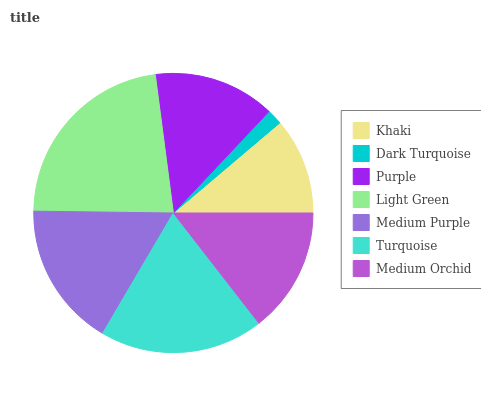Is Dark Turquoise the minimum?
Answer yes or no. Yes. Is Light Green the maximum?
Answer yes or no. Yes. Is Purple the minimum?
Answer yes or no. No. Is Purple the maximum?
Answer yes or no. No. Is Purple greater than Dark Turquoise?
Answer yes or no. Yes. Is Dark Turquoise less than Purple?
Answer yes or no. Yes. Is Dark Turquoise greater than Purple?
Answer yes or no. No. Is Purple less than Dark Turquoise?
Answer yes or no. No. Is Medium Orchid the high median?
Answer yes or no. Yes. Is Medium Orchid the low median?
Answer yes or no. Yes. Is Turquoise the high median?
Answer yes or no. No. Is Light Green the low median?
Answer yes or no. No. 